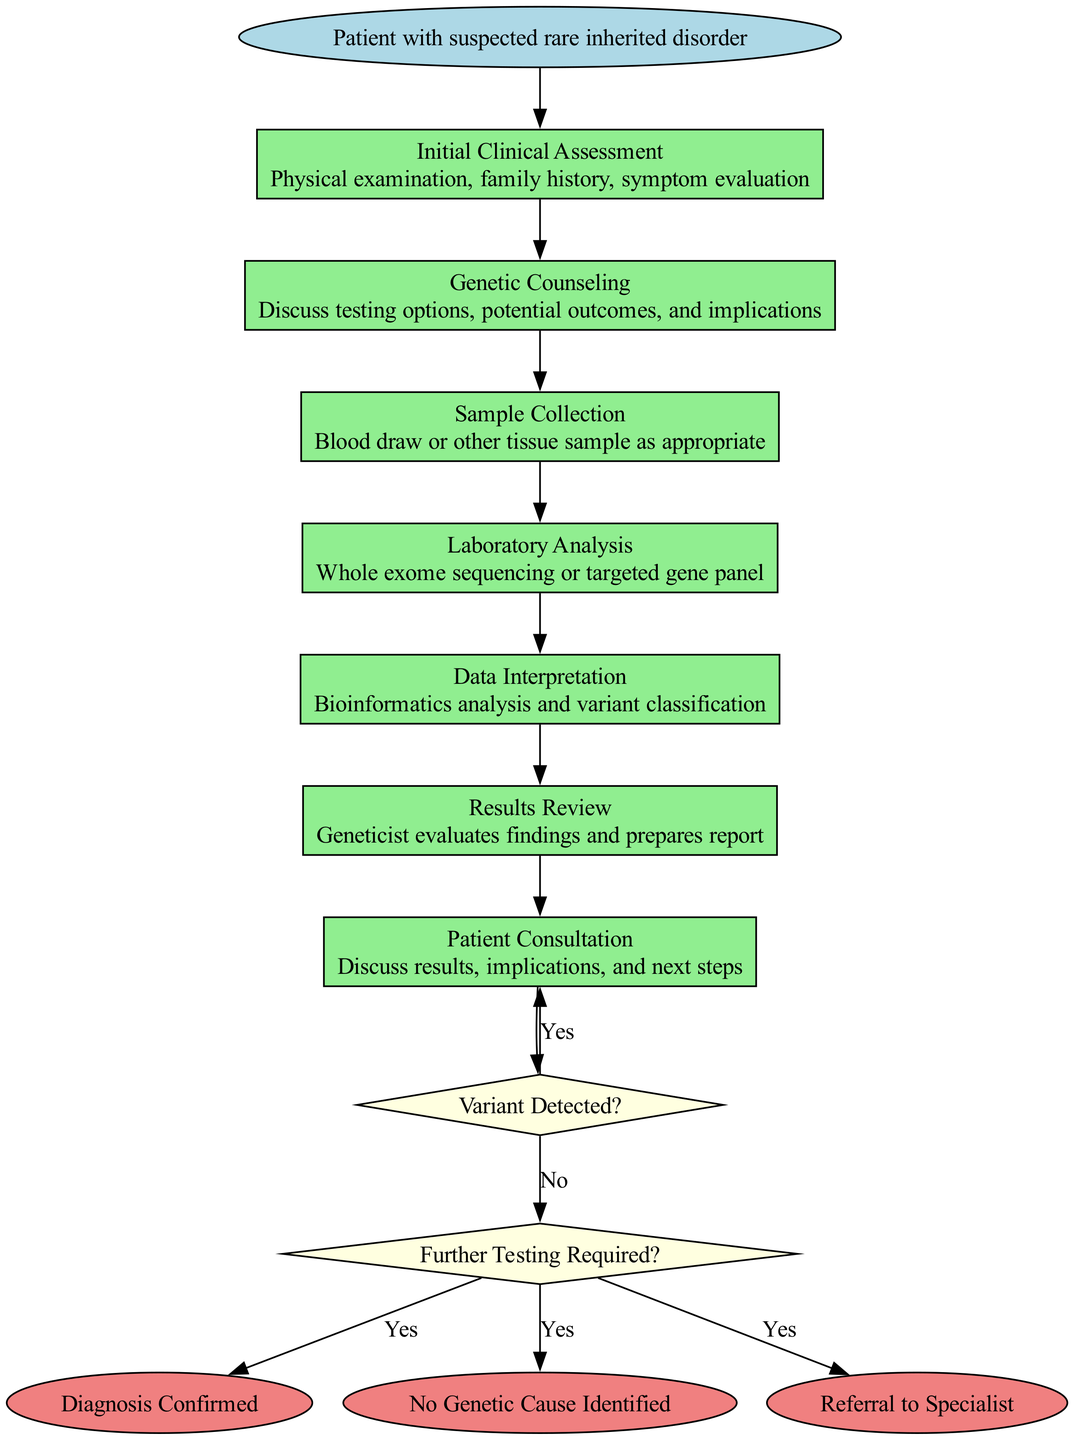What is the starting point of the clinical pathway? The starting point, as indicated in the diagram, is "Patient with suspected rare inherited disorder."
Answer: Patient with suspected rare inherited disorder How many steps are there in the pathway? The diagram outlines a total of 7 steps, each detailing a specific part of the genetic testing process.
Answer: 7 What is the first step in the pathway? The first step, according to the diagram, is "Initial Clinical Assessment."
Answer: Initial Clinical Assessment What follows after the "Laboratory Analysis" step? After "Laboratory Analysis," the next step is "Data Interpretation," as indicated by the flow of the diagram.
Answer: Data Interpretation What decision node appears after "Results Review"? The decision node that appears after "Results Review" is "Variant Detected?" which leads to subsequent steps.
Answer: Variant Detected? If a variant is detected, what is the next step according to the pathway? If a variant is detected, the next step according to the pathway is "Patient Consultation," where results are discussed.
Answer: Patient Consultation How many endpoints are identified in this clinical pathway? There are three endpoints identified in this pathway, each representing possible outcomes of the testing process.
Answer: 3 What does the decision "Further Testing Required?" evaluate? The decision "Further Testing Required?" evaluates whether additional testing needs to be conducted based on initial findings.
Answer: Additional testing What is one of the possible outcomes if no genetic cause is identified? If no genetic cause is identified, one of the possible outcomes is "No Genetic Cause Identified" as shown in the endpoints.
Answer: No Genetic Cause Identified What is the purpose of "Genetic Counseling" in this pathway? The purpose of "Genetic Counseling" is to discuss testing options, potential outcomes, and implications with the patient.
Answer: Discuss testing options, potential outcomes, and implications 